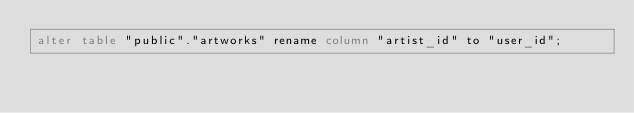Convert code to text. <code><loc_0><loc_0><loc_500><loc_500><_SQL_>alter table "public"."artworks" rename column "artist_id" to "user_id";
</code> 